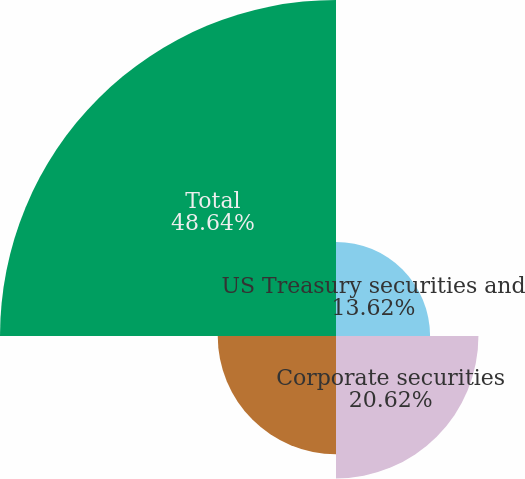Convert chart. <chart><loc_0><loc_0><loc_500><loc_500><pie_chart><fcel>US Treasury securities and<fcel>Corporate securities<fcel>State and municipal securities<fcel>Total<nl><fcel>13.62%<fcel>20.62%<fcel>17.12%<fcel>48.64%<nl></chart> 